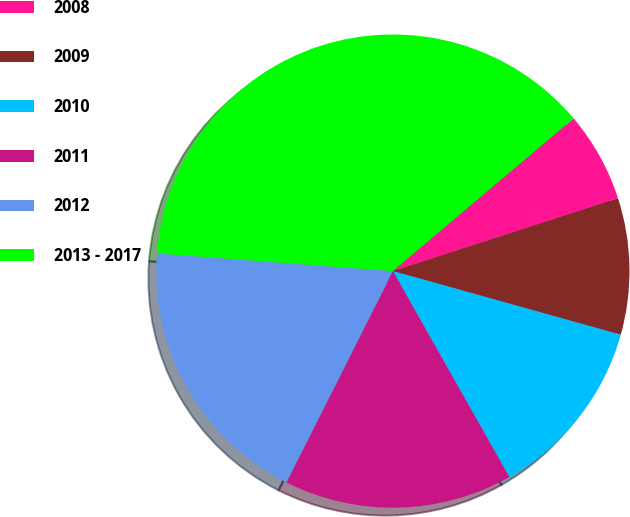Convert chart to OTSL. <chart><loc_0><loc_0><loc_500><loc_500><pie_chart><fcel>2008<fcel>2009<fcel>2010<fcel>2011<fcel>2012<fcel>2013 - 2017<nl><fcel>6.18%<fcel>9.32%<fcel>12.47%<fcel>15.62%<fcel>18.76%<fcel>37.64%<nl></chart> 